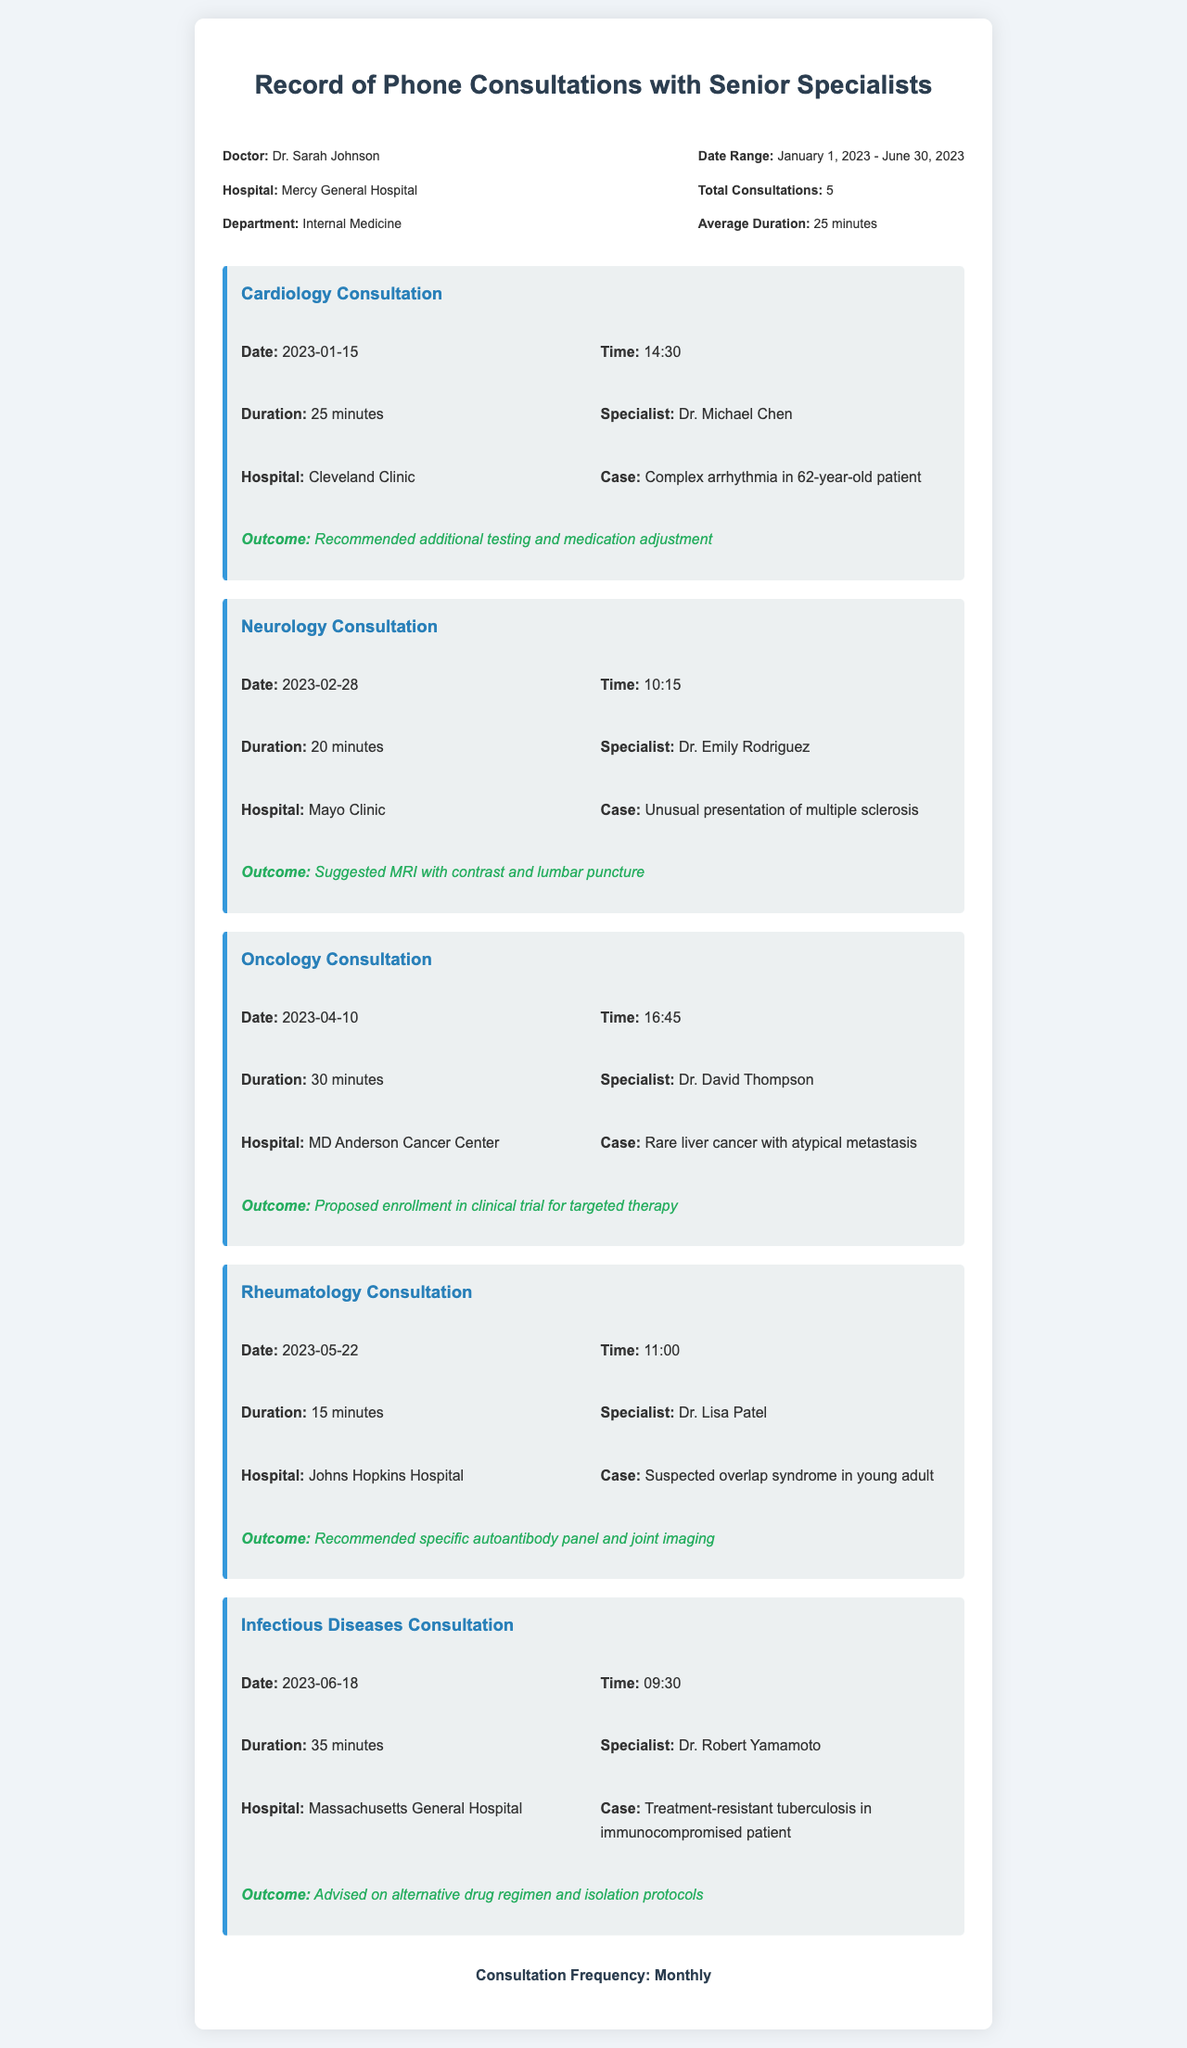What is the doctor's name? The doctor's name is mentioned in the header info of the document.
Answer: Dr. Sarah Johnson How many total consultations were recorded? The total number of consultations is stated in the header info.
Answer: 5 What was the duration of the Cardiology Consultation? The duration is provided in the details of the Cardiology Consultation section.
Answer: 25 minutes Who was the specialist for the Infectious Diseases Consultation? The name of the specialist can be found in the details of the Infectious Diseases Consultation section.
Answer: Dr. Robert Yamamoto What is the case for the Oncology Consultation? The case details are included in the Oncology Consultation section.
Answer: Rare liver cancer with atypical metastasis What was the outcome of the Neurology Consultation? The outcome is specified in the details of the Neurology Consultation section.
Answer: Suggested MRI with contrast and lumbar puncture Which hospital did the Rheumatology Consultation specialist belong to? The hospital name is provided in the details of the Rheumatology Consultation.
Answer: Johns Hopkins Hospital What was the average consultation duration? The average duration can be found in the header info section of the document.
Answer: 25 minutes When was the last consultation recorded? The date of the last consultation is listed in the details of the Infectious Diseases Consultation section.
Answer: 2023-06-18 